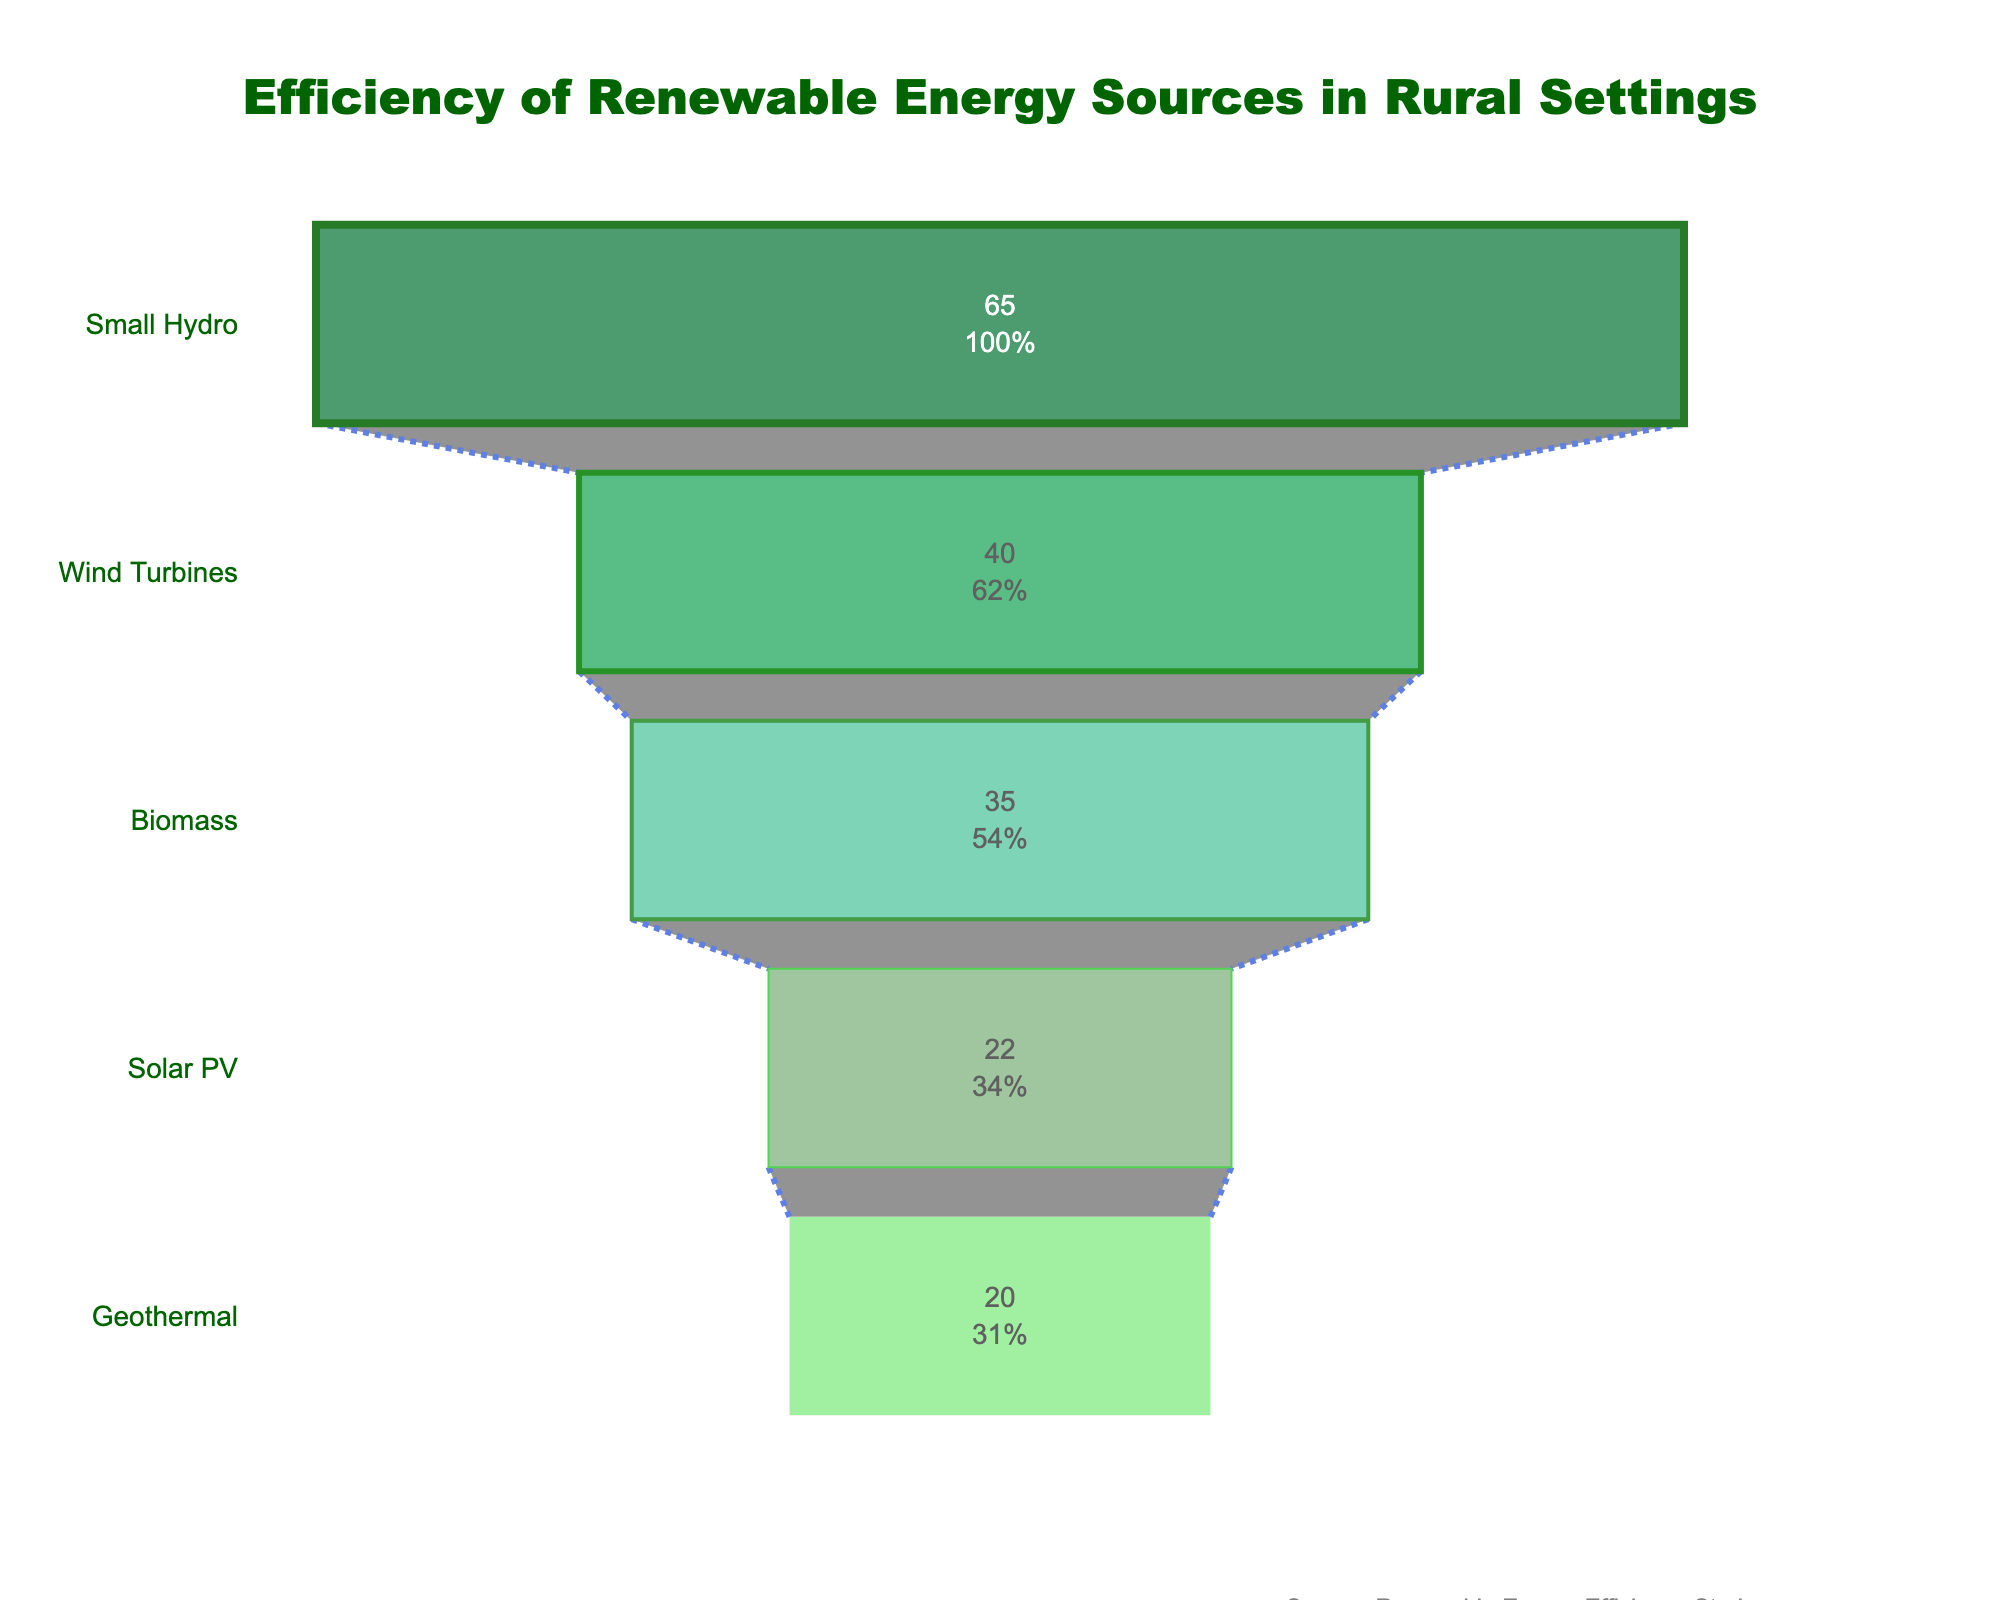What is the title of the figure? The title is displayed at the top of the figure and reads "Efficiency of Renewable Energy Sources in Rural Settings".
Answer: Efficiency of Renewable Energy Sources in Rural Settings Which renewable energy source is shown to be the most efficient in rural settings? The most efficient source is at the widest part of the funnel, which is "Small Hydro" with an efficiency of 65%.
Answer: Small Hydro What is the efficiency percentage of Biomass? The efficiency percentage of Biomass can be seen directly from its section in the funnel, which is 35%.
Answer: 35% Which energy source is less efficient than Wind Turbines but more efficient than Solar PV? By reviewing the funnel chart, Biomass is positioned between Wind Turbines and Solar PV in terms of efficiency.
Answer: Biomass What is the total sum of efficiency percentages of Geothermal and Solar PV? Adding the efficiencies of Geothermal (20%) and Solar PV (22%) gives a total efficiency of 42%.
Answer: 42% Is Wind Turbines more efficient than Biomass? Wind Turbines has an efficiency of 40%, while Biomass has an efficiency of 35%, making Wind Turbines more efficient than Biomass.
Answer: Yes List the renewable energy sources in descending order of efficiency. The renewable energy sources from most efficient to least efficient are: Small Hydro (65%), Wind Turbines (40%), Biomass (35%), Solar PV (22%), and Geothermal (20%).
Answer: Small Hydro, Wind Turbines, Biomass, Solar PV, Geothermal What percentage of efficiency does Geothermal contribute relative to Small Hydro? The efficiency of Geothermal is 20%, and Small Hydro is 65%. Calculating 20/65 x 100 gives approximately 30.77%.
Answer: 30.77% How much more efficient are Wind Turbines compared to Solar PV? Subtracting the efficiency of Solar PV (22%) from Wind Turbines (40%) provides a difference of 18%.
Answer: 18% What is the color of the section representing the least efficient energy source? The section representing the least efficient energy source, Geothermal, is colored light green.
Answer: Light green 